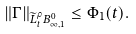Convert formula to latex. <formula><loc_0><loc_0><loc_500><loc_500>\| \Gamma \| _ { \widetilde { L } ^ { \rho } _ { t } B _ { \infty , 1 } ^ { 0 } } \leq \Phi _ { 1 } ( t ) .</formula> 